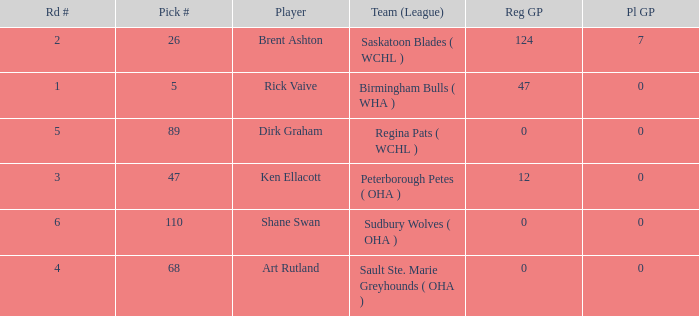How many reg GP for rick vaive in round 1? None. 